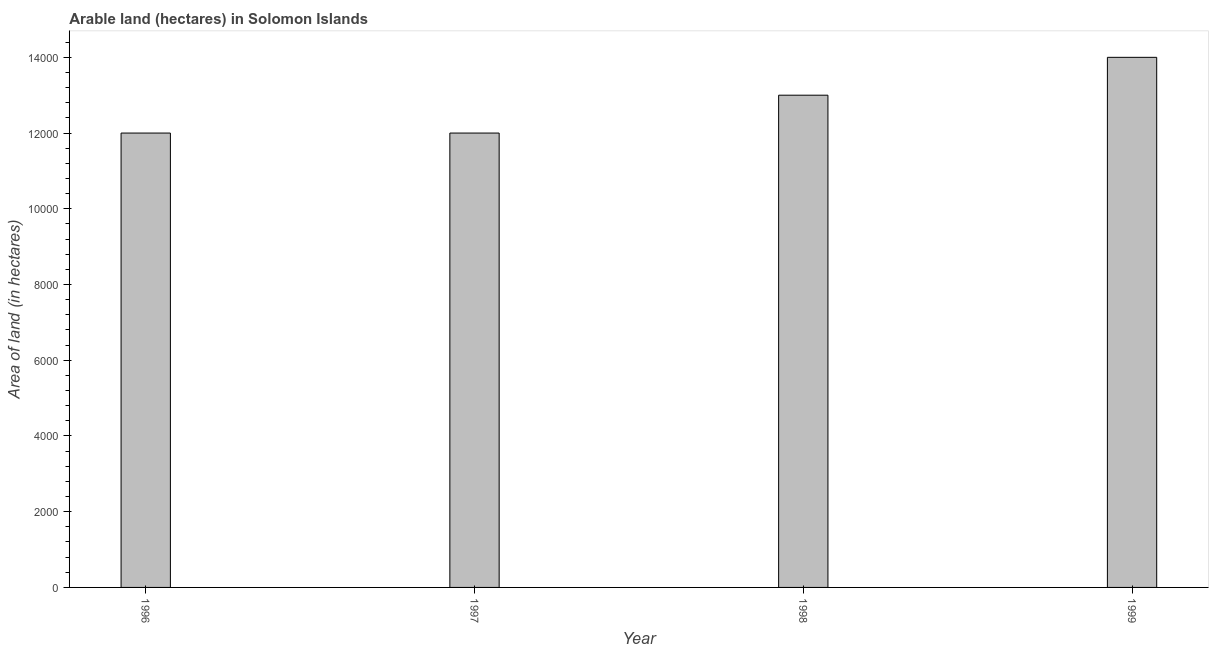What is the title of the graph?
Make the answer very short. Arable land (hectares) in Solomon Islands. What is the label or title of the X-axis?
Ensure brevity in your answer.  Year. What is the label or title of the Y-axis?
Your response must be concise. Area of land (in hectares). What is the area of land in 1999?
Provide a succinct answer. 1.40e+04. Across all years, what is the maximum area of land?
Provide a short and direct response. 1.40e+04. Across all years, what is the minimum area of land?
Your response must be concise. 1.20e+04. What is the sum of the area of land?
Provide a short and direct response. 5.10e+04. What is the difference between the area of land in 1996 and 1997?
Your answer should be compact. 0. What is the average area of land per year?
Provide a succinct answer. 1.28e+04. What is the median area of land?
Your answer should be compact. 1.25e+04. What is the ratio of the area of land in 1996 to that in 1998?
Provide a succinct answer. 0.92. Is the difference between the area of land in 1996 and 1998 greater than the difference between any two years?
Provide a short and direct response. No. Is the sum of the area of land in 1996 and 1998 greater than the maximum area of land across all years?
Offer a terse response. Yes. How many years are there in the graph?
Your answer should be very brief. 4. What is the Area of land (in hectares) in 1996?
Keep it short and to the point. 1.20e+04. What is the Area of land (in hectares) of 1997?
Your answer should be compact. 1.20e+04. What is the Area of land (in hectares) of 1998?
Offer a terse response. 1.30e+04. What is the Area of land (in hectares) in 1999?
Your answer should be very brief. 1.40e+04. What is the difference between the Area of land (in hectares) in 1996 and 1997?
Your response must be concise. 0. What is the difference between the Area of land (in hectares) in 1996 and 1998?
Keep it short and to the point. -1000. What is the difference between the Area of land (in hectares) in 1996 and 1999?
Offer a very short reply. -2000. What is the difference between the Area of land (in hectares) in 1997 and 1998?
Provide a short and direct response. -1000. What is the difference between the Area of land (in hectares) in 1997 and 1999?
Offer a very short reply. -2000. What is the difference between the Area of land (in hectares) in 1998 and 1999?
Provide a short and direct response. -1000. What is the ratio of the Area of land (in hectares) in 1996 to that in 1998?
Offer a terse response. 0.92. What is the ratio of the Area of land (in hectares) in 1996 to that in 1999?
Offer a terse response. 0.86. What is the ratio of the Area of land (in hectares) in 1997 to that in 1998?
Your answer should be compact. 0.92. What is the ratio of the Area of land (in hectares) in 1997 to that in 1999?
Make the answer very short. 0.86. What is the ratio of the Area of land (in hectares) in 1998 to that in 1999?
Offer a terse response. 0.93. 